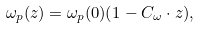Convert formula to latex. <formula><loc_0><loc_0><loc_500><loc_500>\omega _ { p } ( z ) = \omega _ { p } ( 0 ) ( 1 - C _ { \omega } \cdot z ) ,</formula> 